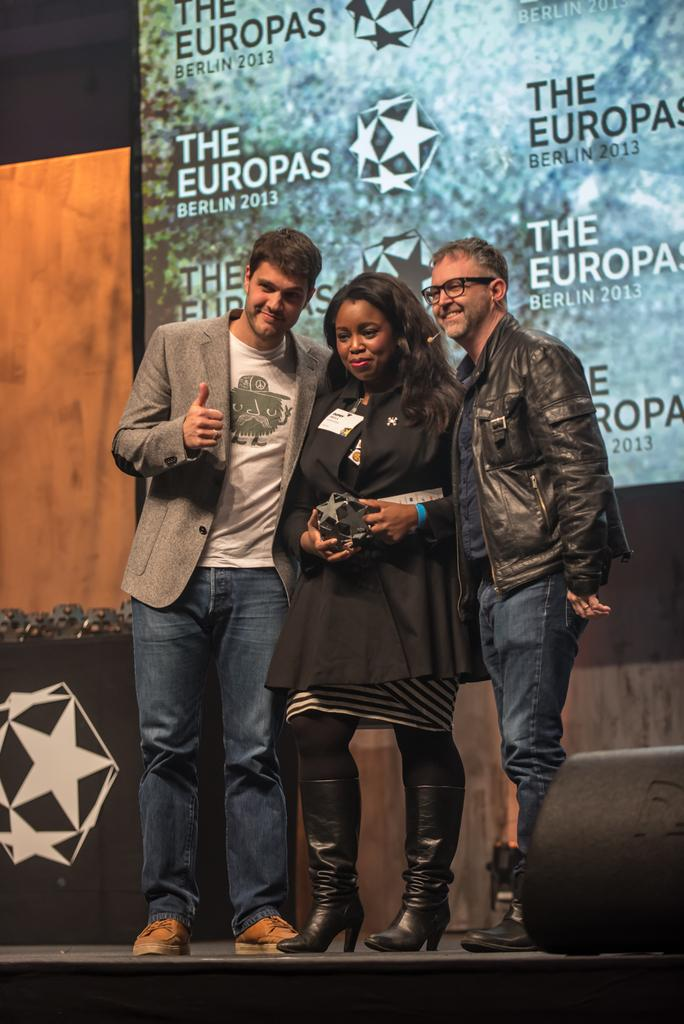What can be seen in the image involving human subjects? There are people standing in the image. What are the people wearing? The people are wearing clothes. What object is present in the image besides the people? There is a board in the image. What type of tramp can be seen jumping on the board in the image? There is no tramp or board present in the image; it only features people standing and wearing clothes. How many roses are visible in the image? There are no roses present in the image. 